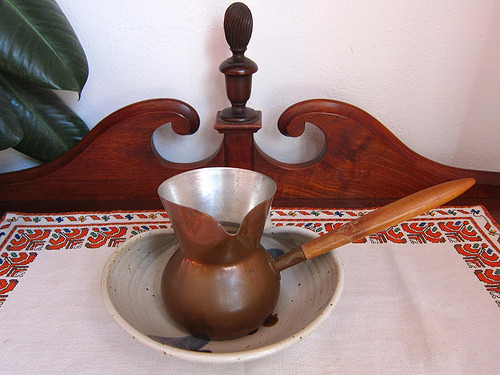<image>
Is the serving piece on the table? Yes. Looking at the image, I can see the serving piece is positioned on top of the table, with the table providing support. 